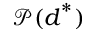<formula> <loc_0><loc_0><loc_500><loc_500>\mathcal { P } ( d ^ { * } )</formula> 